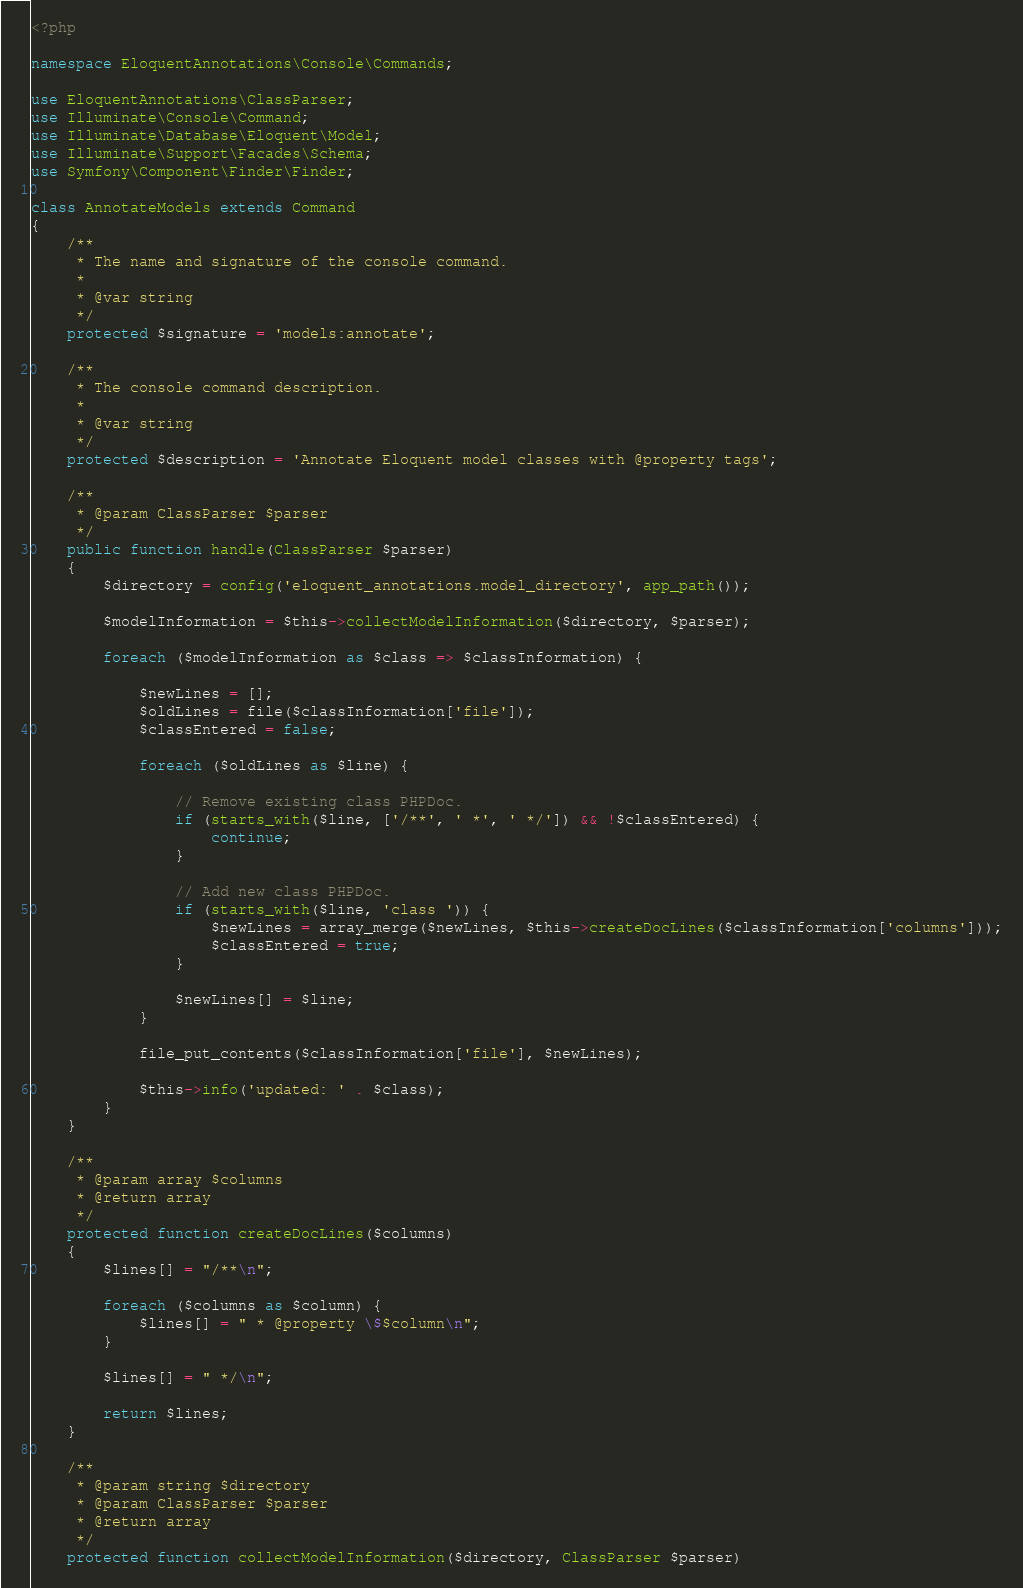Convert code to text. <code><loc_0><loc_0><loc_500><loc_500><_PHP_><?php

namespace EloquentAnnotations\Console\Commands;

use EloquentAnnotations\ClassParser;
use Illuminate\Console\Command;
use Illuminate\Database\Eloquent\Model;
use Illuminate\Support\Facades\Schema;
use Symfony\Component\Finder\Finder;

class AnnotateModels extends Command
{
    /**
     * The name and signature of the console command.
     *
     * @var string
     */
    protected $signature = 'models:annotate';

    /**
     * The console command description.
     *
     * @var string
     */
    protected $description = 'Annotate Eloquent model classes with @property tags';

    /**
     * @param ClassParser $parser
     */
    public function handle(ClassParser $parser)
    {
        $directory = config('eloquent_annotations.model_directory', app_path());

        $modelInformation = $this->collectModelInformation($directory, $parser);

        foreach ($modelInformation as $class => $classInformation) {

            $newLines = [];
            $oldLines = file($classInformation['file']);
            $classEntered = false;

            foreach ($oldLines as $line) {

                // Remove existing class PHPDoc.
                if (starts_with($line, ['/**', ' *', ' */']) && !$classEntered) {
                    continue;
                }

                // Add new class PHPDoc.
                if (starts_with($line, 'class ')) {
                    $newLines = array_merge($newLines, $this->createDocLines($classInformation['columns']));
                    $classEntered = true;
                }

                $newLines[] = $line;
            }

            file_put_contents($classInformation['file'], $newLines);

            $this->info('updated: ' . $class);
        }
    }

    /**
     * @param array $columns
     * @return array
     */
    protected function createDocLines($columns)
    {
        $lines[] = "/**\n";

        foreach ($columns as $column) {
            $lines[] = " * @property \$$column\n";
        }

        $lines[] = " */\n";

        return $lines;
    }

    /**
     * @param string $directory
     * @param ClassParser $parser
     * @return array
     */
    protected function collectModelInformation($directory, ClassParser $parser)</code> 